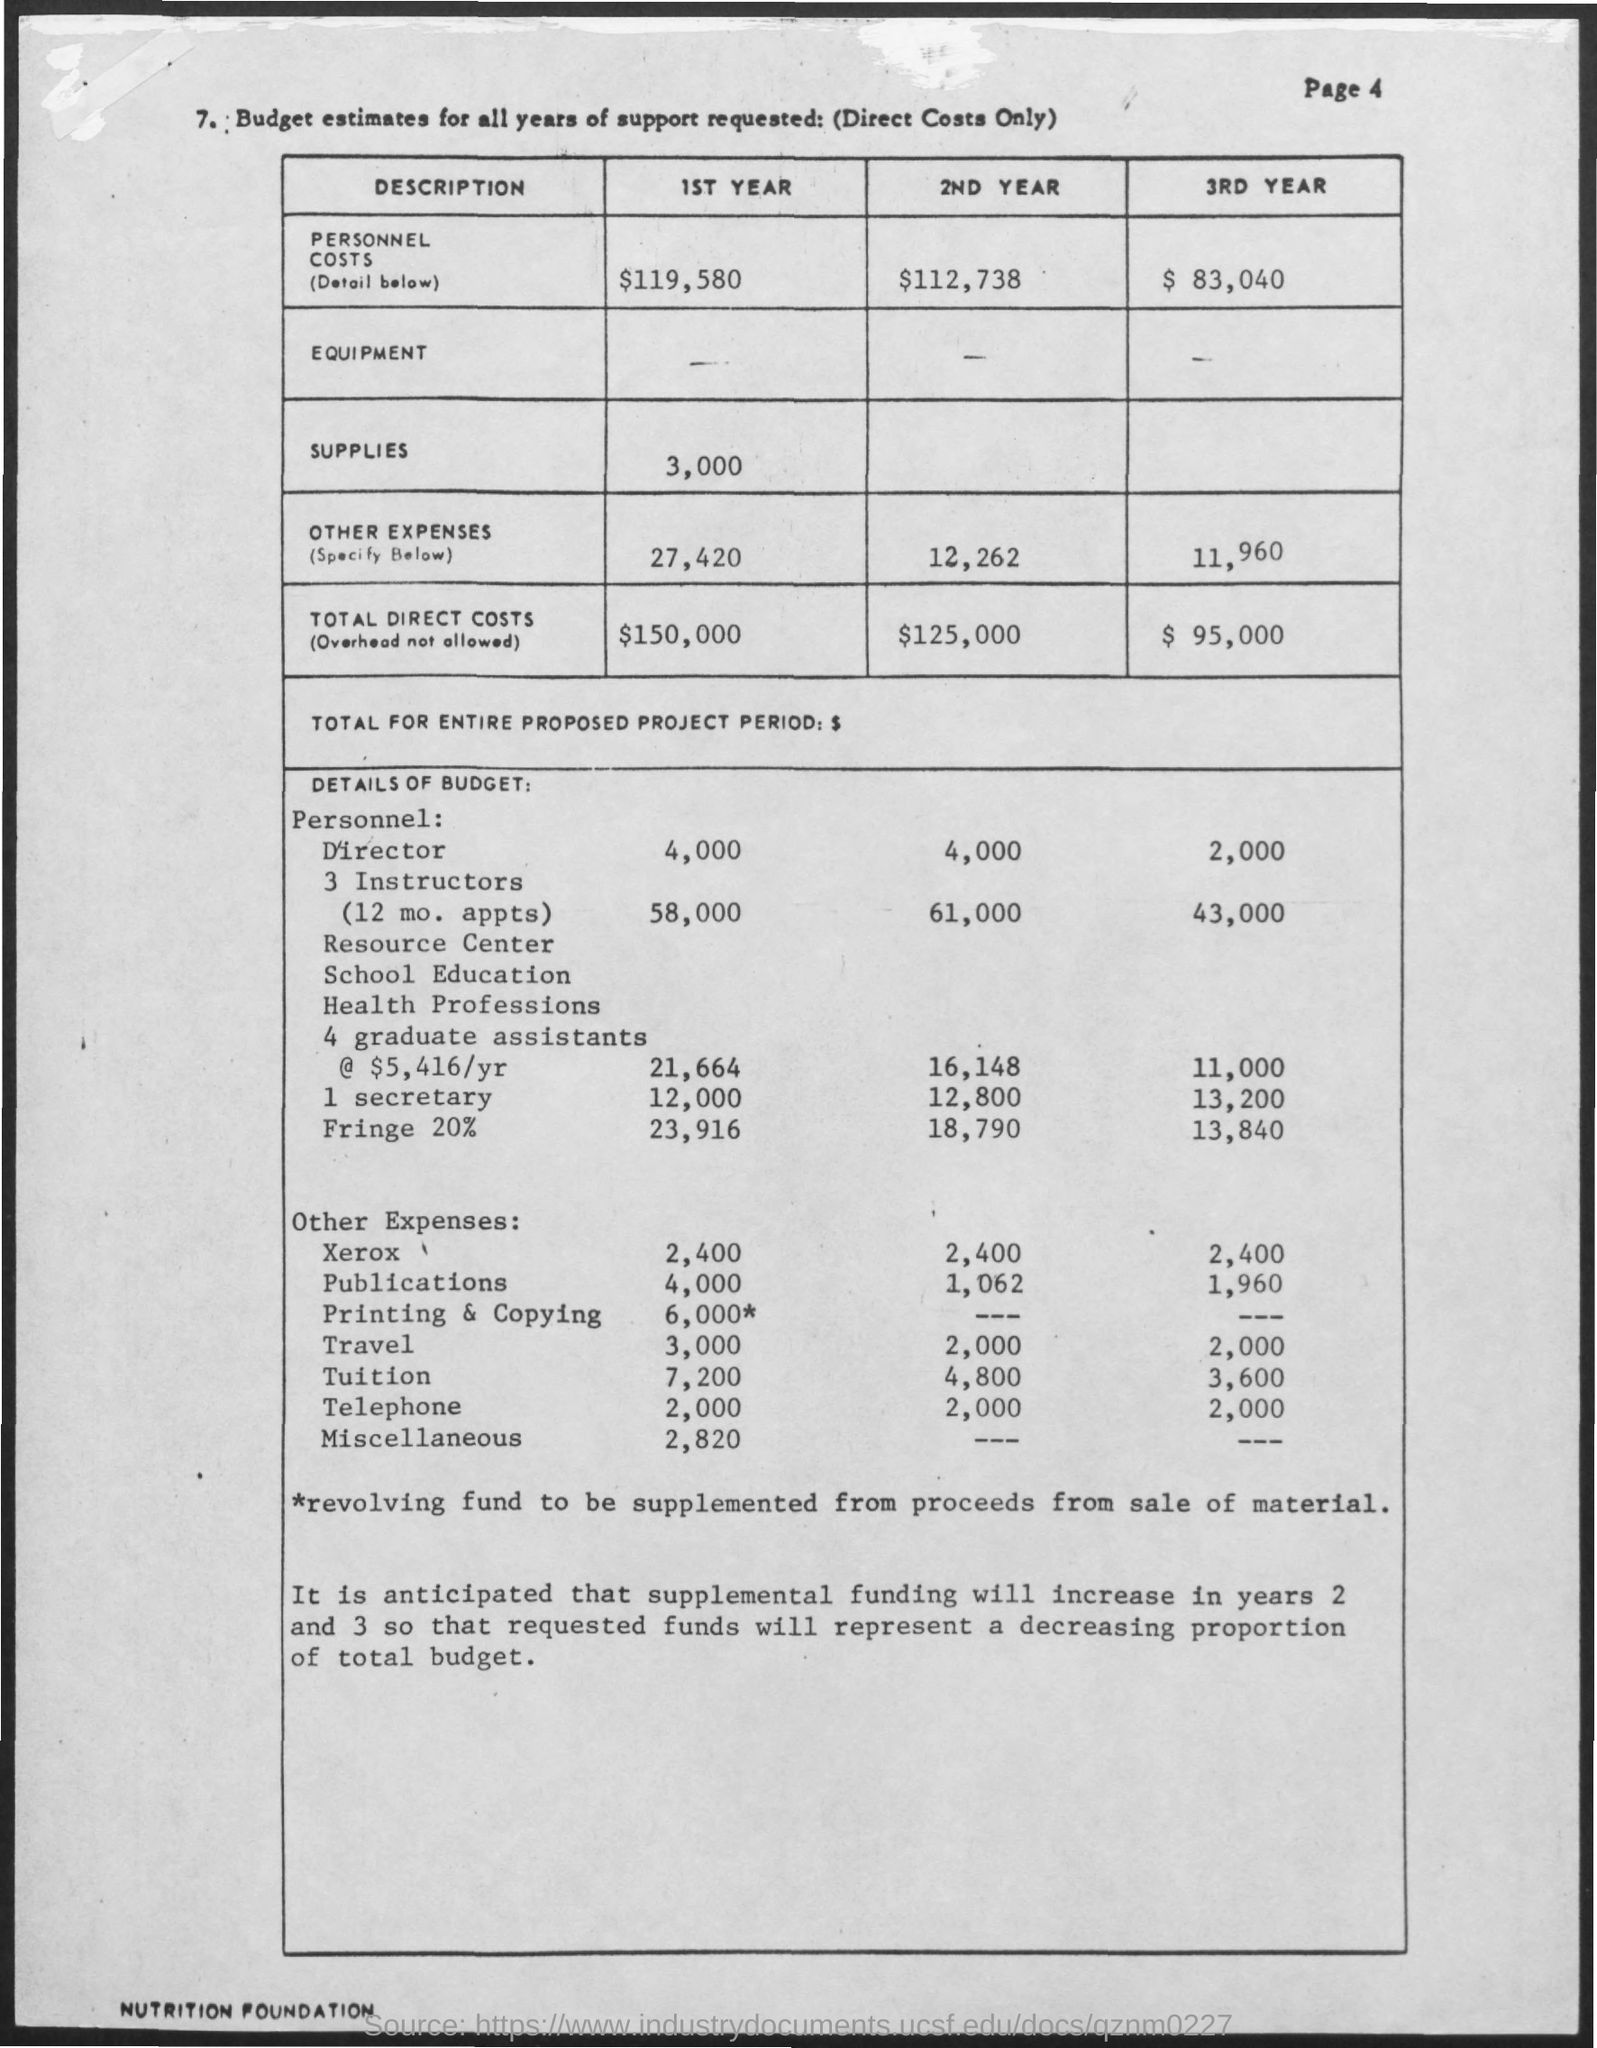Mention a couple of crucial points in this snapshot. The amount for supplies mentioned in the first year is $3,000. The personnel costs mentioned in the third year are $83,040. The personnel costs for the second year are stated to be $112,738. The total direct costs mentioned in the second year are $125,000. The amount for personnel costs mentioned in the first year is $119,580. 